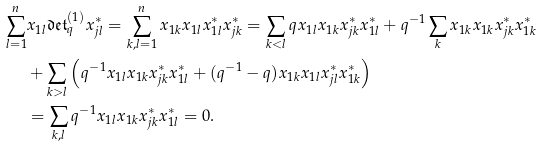Convert formula to latex. <formula><loc_0><loc_0><loc_500><loc_500>\sum _ { l = 1 } ^ { n } & x _ { 1 l } \mathfrak { d e t } _ { q } ^ { ( 1 ) } x _ { j l } ^ { * } = \sum _ { k , l = 1 } ^ { n } x _ { 1 k } x _ { 1 l } x _ { 1 l } ^ { * } x _ { j k } ^ { * } = \sum _ { k < l } q x _ { 1 l } x _ { 1 k } x _ { j k } ^ { * } x _ { 1 l } ^ { * } + q ^ { - 1 } \sum _ { k } x _ { 1 k } x _ { 1 k } x _ { j k } ^ { * } x _ { 1 k } ^ { * } \\ & + \sum _ { k > l } \left ( q ^ { - 1 } x _ { 1 l } x _ { 1 k } x _ { j k } ^ { * } x _ { 1 l } ^ { * } + ( q ^ { - 1 } - q ) x _ { 1 k } x _ { 1 l } x _ { j l } ^ { * } x _ { 1 k } ^ { * } \right ) \\ & = \sum _ { k , l } q ^ { - 1 } x _ { 1 l } x _ { 1 k } x _ { j k } ^ { * } x _ { 1 l } ^ { * } = 0 .</formula> 